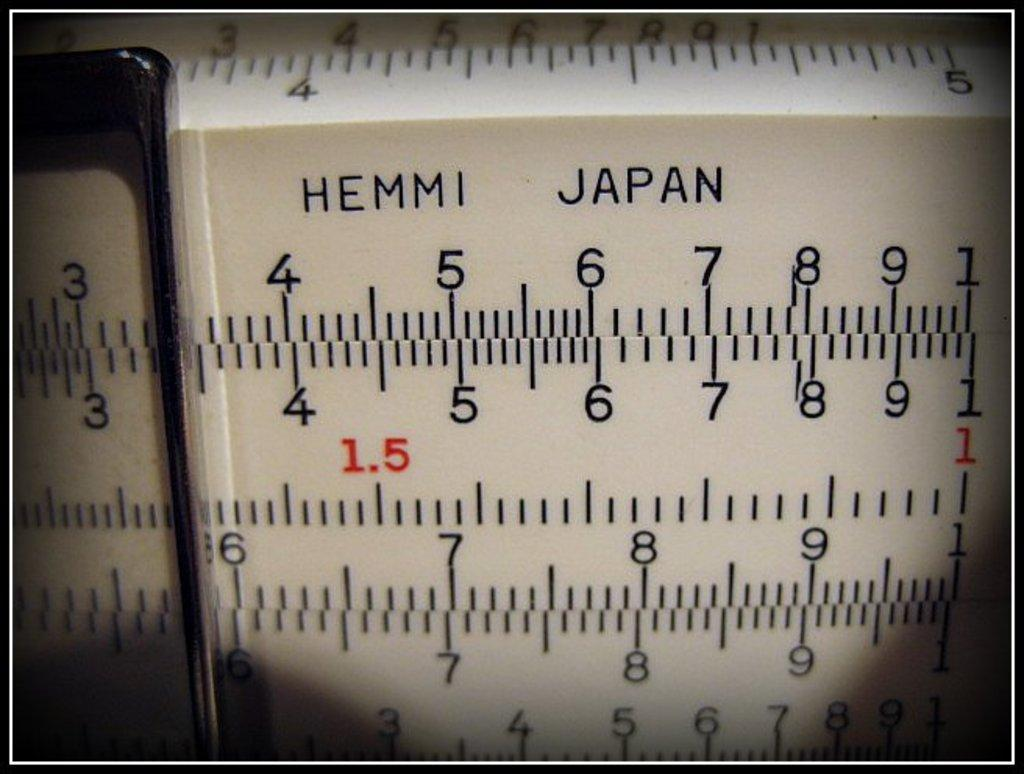<image>
Provide a brief description of the given image. Ruler that says HEMMI Japan and has many numbers on it. 